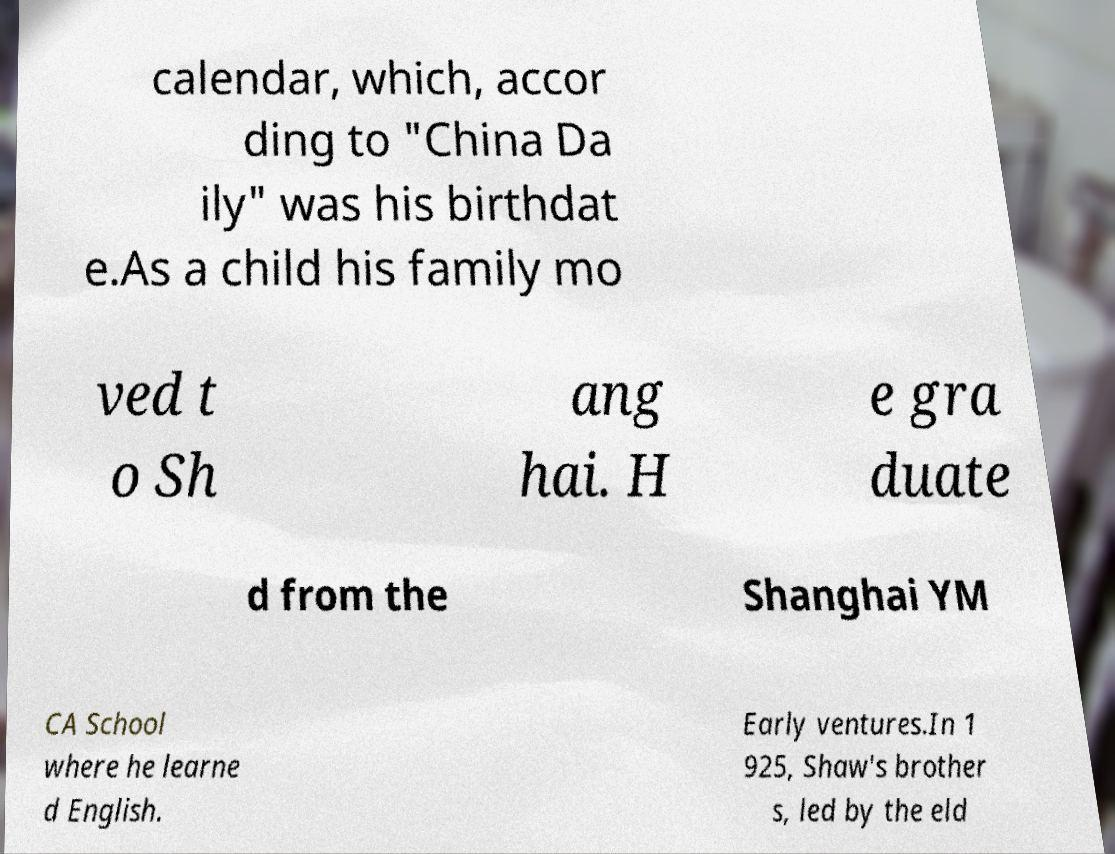There's text embedded in this image that I need extracted. Can you transcribe it verbatim? calendar, which, accor ding to "China Da ily" was his birthdat e.As a child his family mo ved t o Sh ang hai. H e gra duate d from the Shanghai YM CA School where he learne d English. Early ventures.In 1 925, Shaw's brother s, led by the eld 